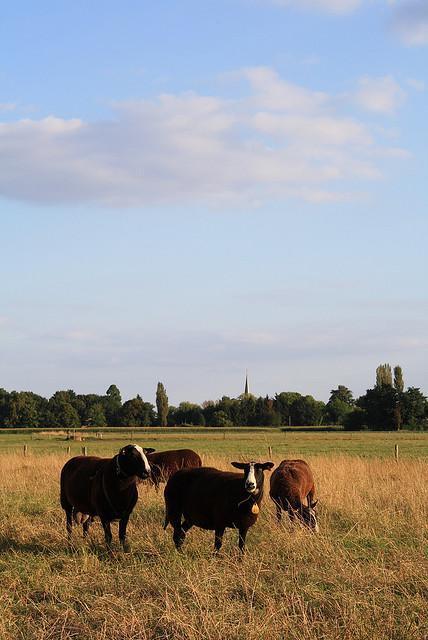How many legs are on the sheep above?
Give a very brief answer. 4. How many cows?
Give a very brief answer. 4. How many animals can be seen?
Give a very brief answer. 4. How many cows are in the picture?
Give a very brief answer. 3. How many sheep can be seen?
Give a very brief answer. 2. How many blue keyboards are there?
Give a very brief answer. 0. 